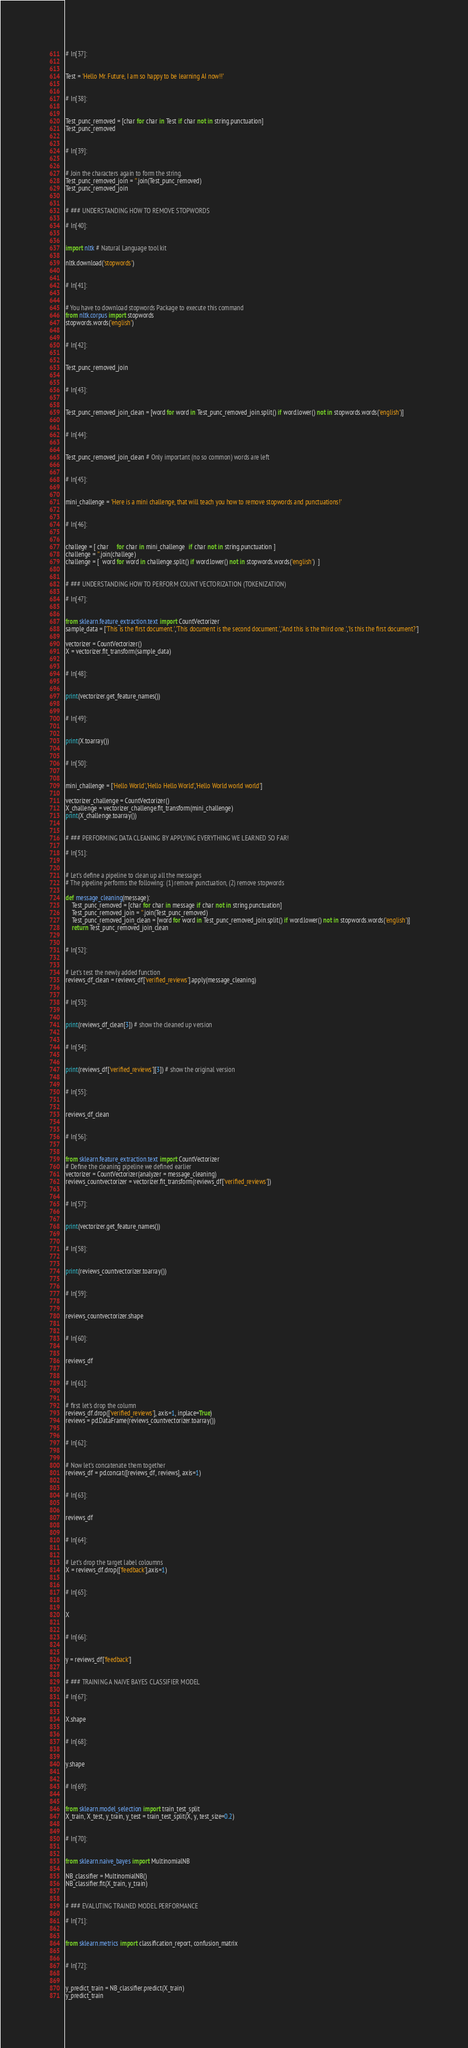Convert code to text. <code><loc_0><loc_0><loc_500><loc_500><_Python_>
# In[37]:


Test = 'Hello Mr. Future, I am so happy to be learning AI now!!'


# In[38]:


Test_punc_removed = [char for char in Test if char not in string.punctuation]
Test_punc_removed


# In[39]:


# Join the characters again to form the string.
Test_punc_removed_join = ''.join(Test_punc_removed)
Test_punc_removed_join


# ### UNDERSTANDING HOW TO REMOVE STOPWORDS

# In[40]:


import nltk # Natural Language tool kit 

nltk.download('stopwords')


# In[41]:


# You have to download stopwords Package to execute this command
from nltk.corpus import stopwords
stopwords.words('english')


# In[42]:


Test_punc_removed_join


# In[43]:


Test_punc_removed_join_clean = [word for word in Test_punc_removed_join.split() if word.lower() not in stopwords.words('english')]


# In[44]:


Test_punc_removed_join_clean # Only important (no so common) words are left


# In[45]:


mini_challenge = 'Here is a mini challenge, that will teach you how to remove stopwords and punctuations!'


# In[46]:


challege = [ char     for char in mini_challenge  if char not in string.punctuation ]
challenge = ''.join(challege)
challenge = [  word for word in challenge.split() if word.lower() not in stopwords.words('english')  ] 


# ### UNDERSTANDING HOW TO PERFORM COUNT VECTORIZATION (TOKENIZATION)

# In[47]:


from sklearn.feature_extraction.text import CountVectorizer
sample_data = ['This is the first document.','This document is the second document.','And this is the third one.','Is this the first document?']

vectorizer = CountVectorizer()
X = vectorizer.fit_transform(sample_data)


# In[48]:


print(vectorizer.get_feature_names())


# In[49]:


print(X.toarray())  


# In[50]:


mini_challenge = ['Hello World','Hello Hello World','Hello World world world']

vectorizer_challenge = CountVectorizer()
X_challenge = vectorizer_challenge.fit_transform(mini_challenge)
print(X_challenge.toarray())


# ### PERFORMING DATA CLEANING BY APPLYING EVERYTHING WE LEARNED SO FAR!

# In[51]:


# Let's define a pipeline to clean up all the messages 
# The pipeline performs the following: (1) remove punctuation, (2) remove stopwords

def message_cleaning(message):
    Test_punc_removed = [char for char in message if char not in string.punctuation]
    Test_punc_removed_join = ''.join(Test_punc_removed)
    Test_punc_removed_join_clean = [word for word in Test_punc_removed_join.split() if word.lower() not in stopwords.words('english')]
    return Test_punc_removed_join_clean


# In[52]:


# Let's test the newly added function
reviews_df_clean = reviews_df['verified_reviews'].apply(message_cleaning)


# In[53]:


print(reviews_df_clean[3]) # show the cleaned up version


# In[54]:


print(reviews_df['verified_reviews'][3]) # show the original version


# In[55]:


reviews_df_clean


# In[56]:


from sklearn.feature_extraction.text import CountVectorizer
# Define the cleaning pipeline we defined earlier
vectorizer = CountVectorizer(analyzer = message_cleaning)
reviews_countvectorizer = vectorizer.fit_transform(reviews_df['verified_reviews'])


# In[57]:


print(vectorizer.get_feature_names())


# In[58]:


print(reviews_countvectorizer.toarray())  


# In[59]:


reviews_countvectorizer.shape


# In[60]:


reviews_df


# In[61]:


# first let's drop the column
reviews_df.drop(['verified_reviews'], axis=1, inplace=True)
reviews = pd.DataFrame(reviews_countvectorizer.toarray())


# In[62]:


# Now let's concatenate them together
reviews_df = pd.concat([reviews_df, reviews], axis=1)


# In[63]:


reviews_df


# In[64]:


# Let's drop the target label coloumns
X = reviews_df.drop(['feedback'],axis=1)


# In[65]:


X


# In[66]:


y = reviews_df['feedback']


# ### TRAINING A NAIVE BAYES CLASSIFIER MODEL

# In[67]:


X.shape


# In[68]:


y.shape


# In[69]:


from sklearn.model_selection import train_test_split
X_train, X_test, y_train, y_test = train_test_split(X, y, test_size=0.2)


# In[70]:


from sklearn.naive_bayes import MultinomialNB

NB_classifier = MultinomialNB()
NB_classifier.fit(X_train, y_train)


# ### EVALUTING TRAINED MODEL PERFORMANCE  

# In[71]:


from sklearn.metrics import classification_report, confusion_matrix


# In[72]:


y_predict_train = NB_classifier.predict(X_train)
y_predict_train</code> 